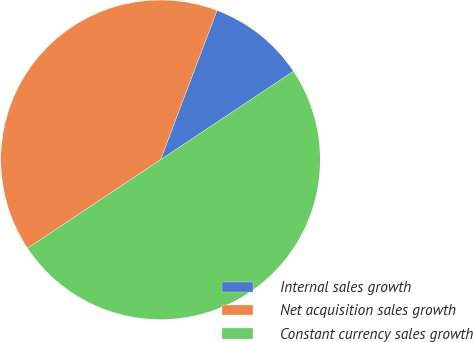Convert chart to OTSL. <chart><loc_0><loc_0><loc_500><loc_500><pie_chart><fcel>Internal sales growth<fcel>Net acquisition sales growth<fcel>Constant currency sales growth<nl><fcel>9.9%<fcel>40.1%<fcel>50.0%<nl></chart> 